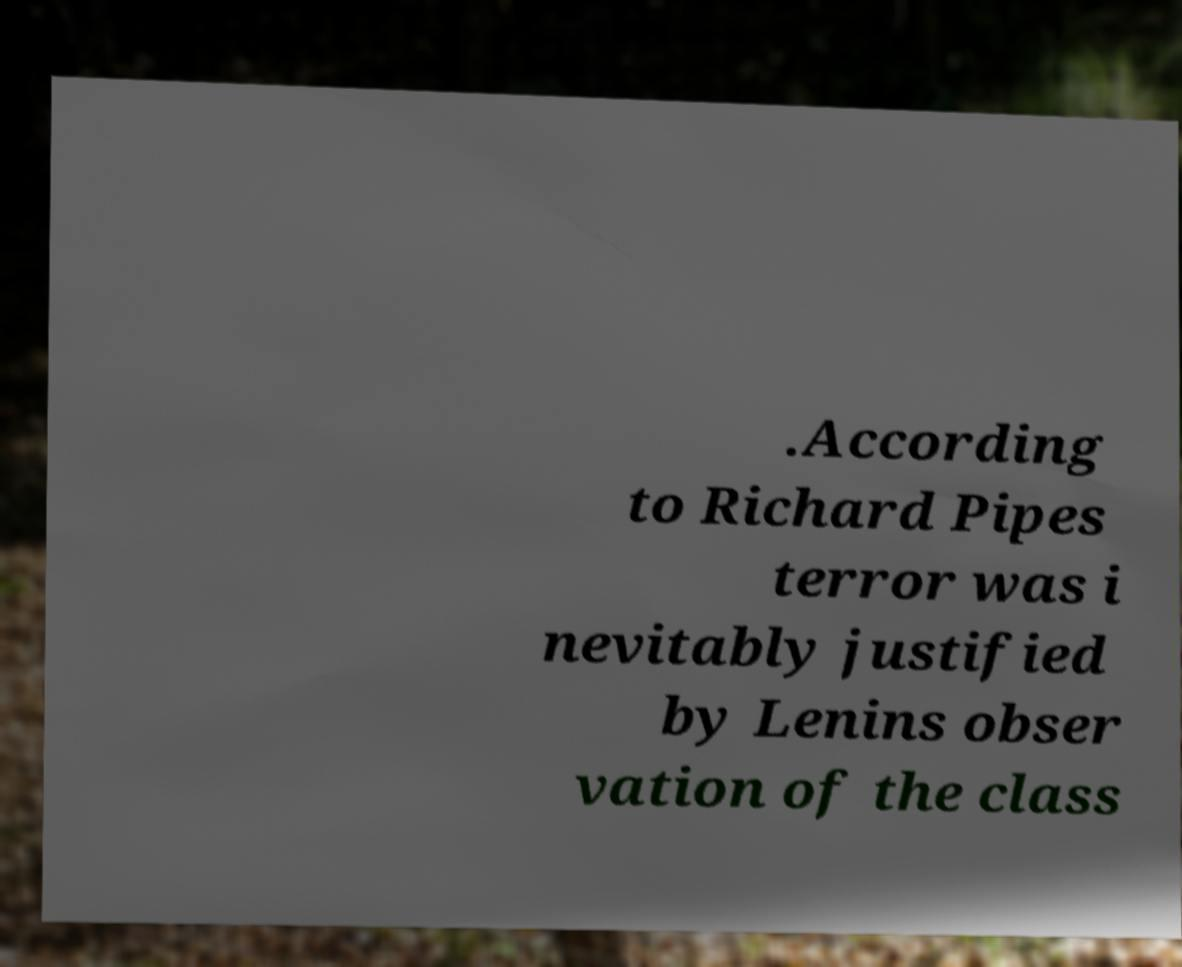What messages or text are displayed in this image? I need them in a readable, typed format. .According to Richard Pipes terror was i nevitably justified by Lenins obser vation of the class 